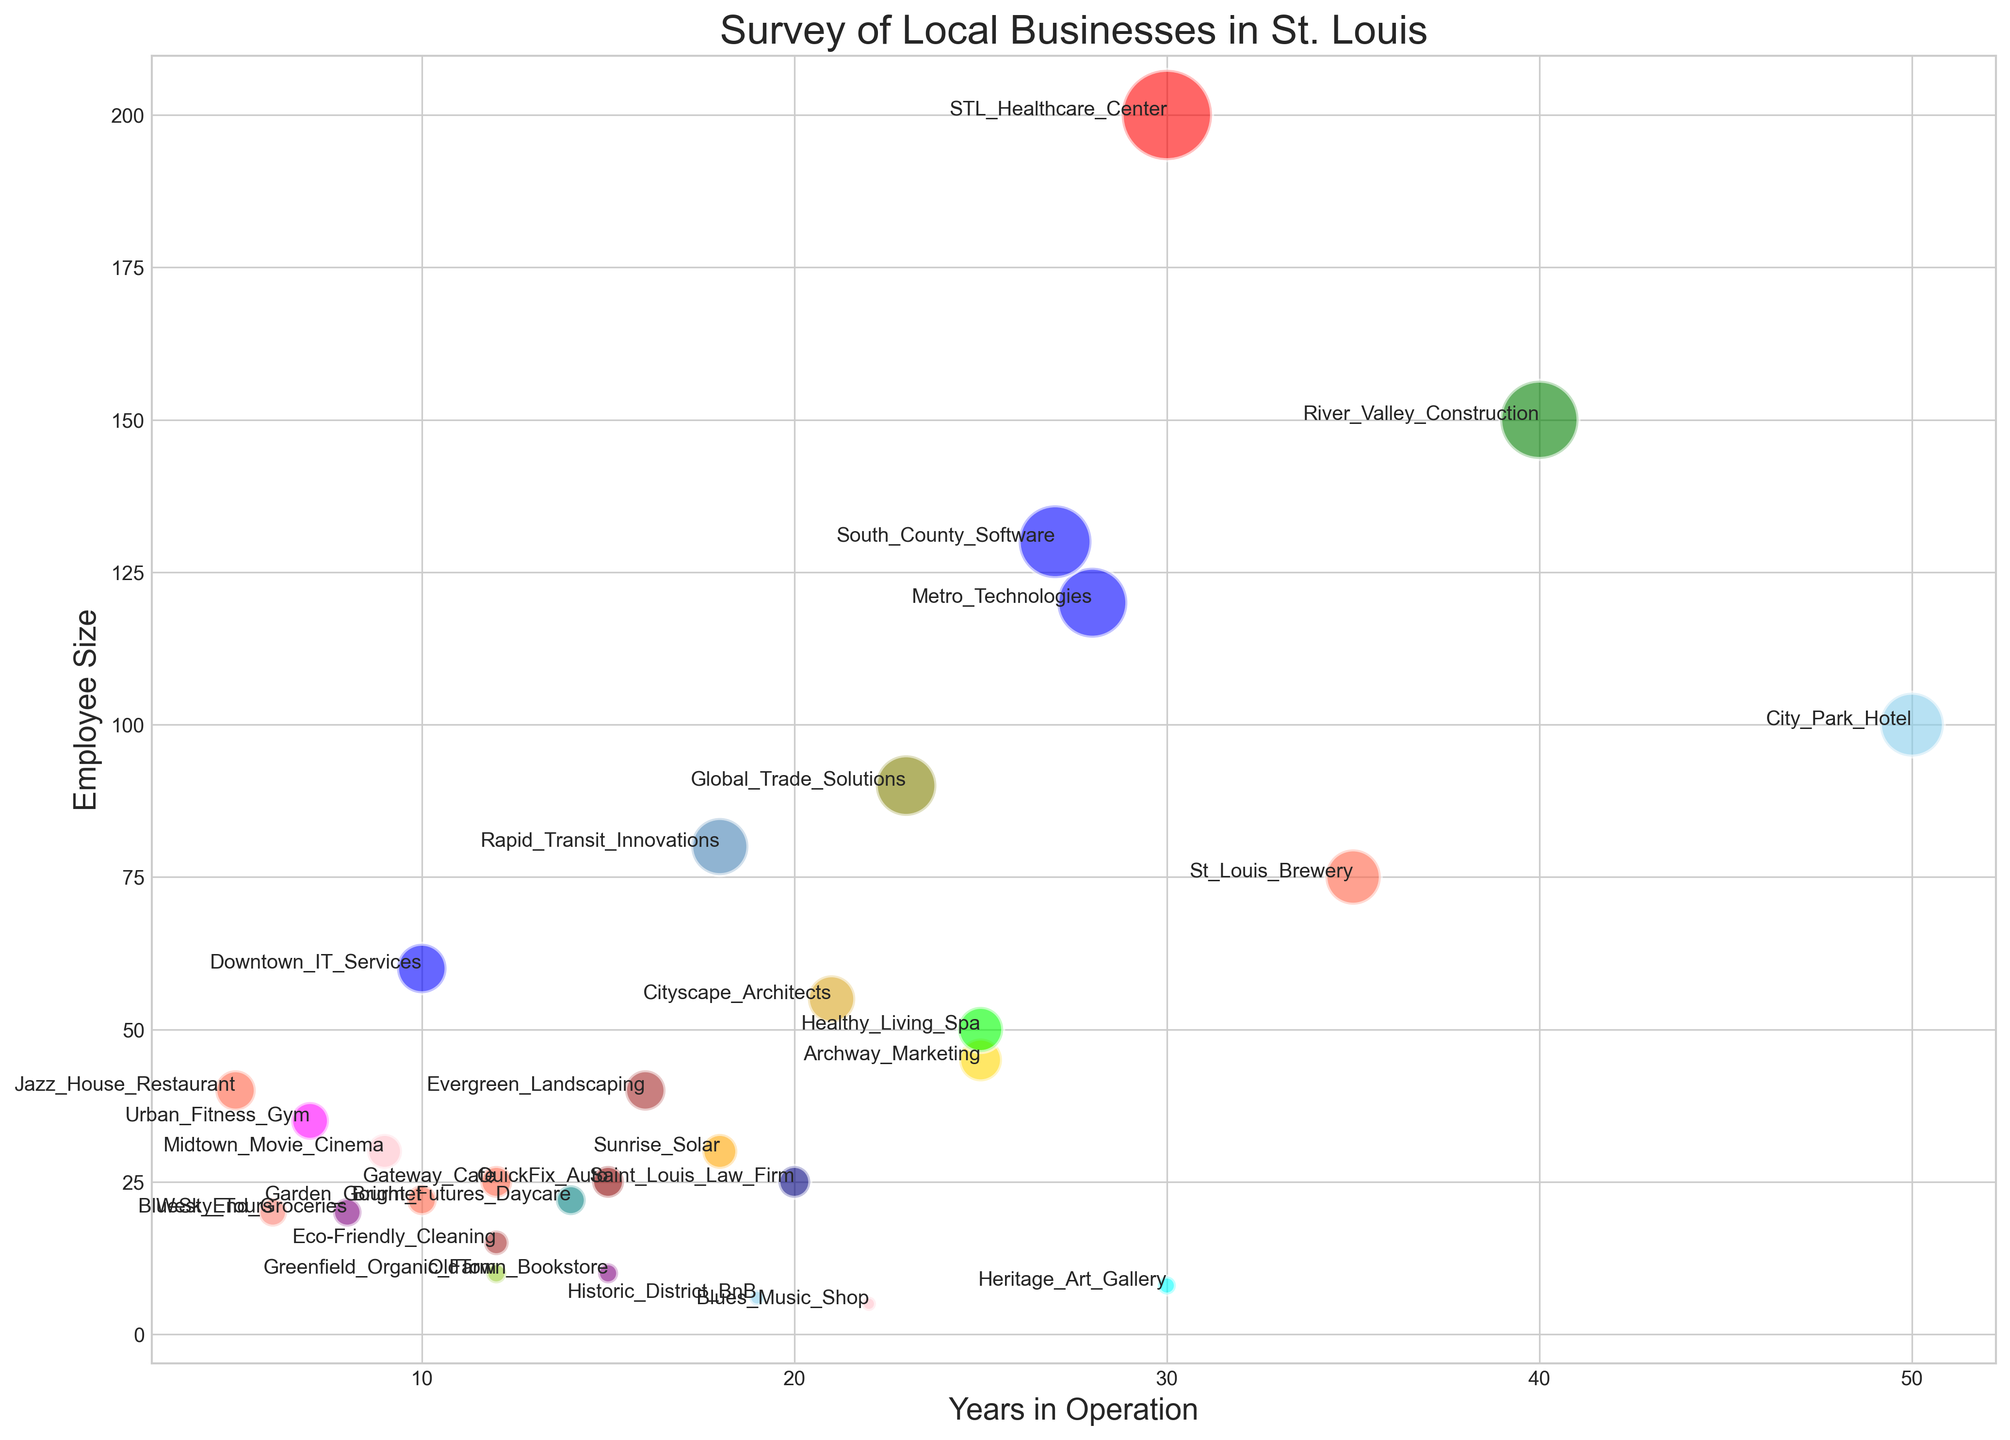Which business has been in operation the longest? Look at the x-axis (Years in Operation) and identify the business name with the highest value. "City Park Hotel" is operating for 50 years, the longest among all the businesses.
Answer: City Park Hotel Which industry sector has the largest business by employee size? Find the y-axis (Employee Size) and spot the highest bubble. The "Healthcare" sector, with the "STL Healthcare Center" having 200 employees, is the largest.
Answer: Healthcare Which business is marked with a pink bubble? Identify the color pink in the scatter plot. "Blues Music Shop" in the "Entertainment" sector is marked with a pink bubble.
Answer: Blues Music Shop Are there any businesses with a similar number of employees but significantly different years in operation? Compare businesses along the y-axis to see those with close employee sizes but check their x-axis values for disparity. "Archway Marketing" and "Healthy Living Spa" both have around 50 employees but differ significantly in operation years; 25 vs. 10 years respectively.
Answer: Archway Marketing and Healthy Living Spa What is the employee size range for the Technology sector? Identify all blue bubbles and note their employee sizes. "Downtown IT Services" (60), "Metro Technologies" (120), and "South County Software" (130) ranges from 60 to 130 employees.
Answer: 60 to 130 How many businesses have fewer than 10 years in operation? Count all bubbles with x-axis values below 10. Businesses like "West End Groceries," "Jazz House Restaurant," "Urban Fitness Gym," etc., total a count of 4.
Answer: 4 Which business operates in the “Agriculture” sector? Look for a yellow-green bubble, which signifies the agriculture sector. "Greenfield Organic Farm" fits this description.
Answer: Greenfield Organic Farm Which business has the smallest bubble? The smallest bubble is indicative of the smallest employee size on the chart. "Blues Music Shop" with only 5 employees appears to have the smallest bubble.
Answer: Blues Music Shop Which sector contains businesses with an operation span ranging from 14 to 22 years? Check the x-axis and identify sectors overlapping within 14 to 22 years. "Retail" (OldTown Bookstore), "Services" (Eco-Friendly Cleaning), "Technology" (Downtown IT Services), and "Healthcare" (Saint Louis Law Firm) sectors span this range.
Answer: Retail, Services, Technology, Healthcare Which industry sector has the most diverse range in employee size? Evaluate all colors to find the sector with the largest spread along the y-axis. The "Technology" sector ranges from 60 ("Downtown IT Services") to 130 ("South County Software") employees, showing wide diversity.
Answer: Technology 